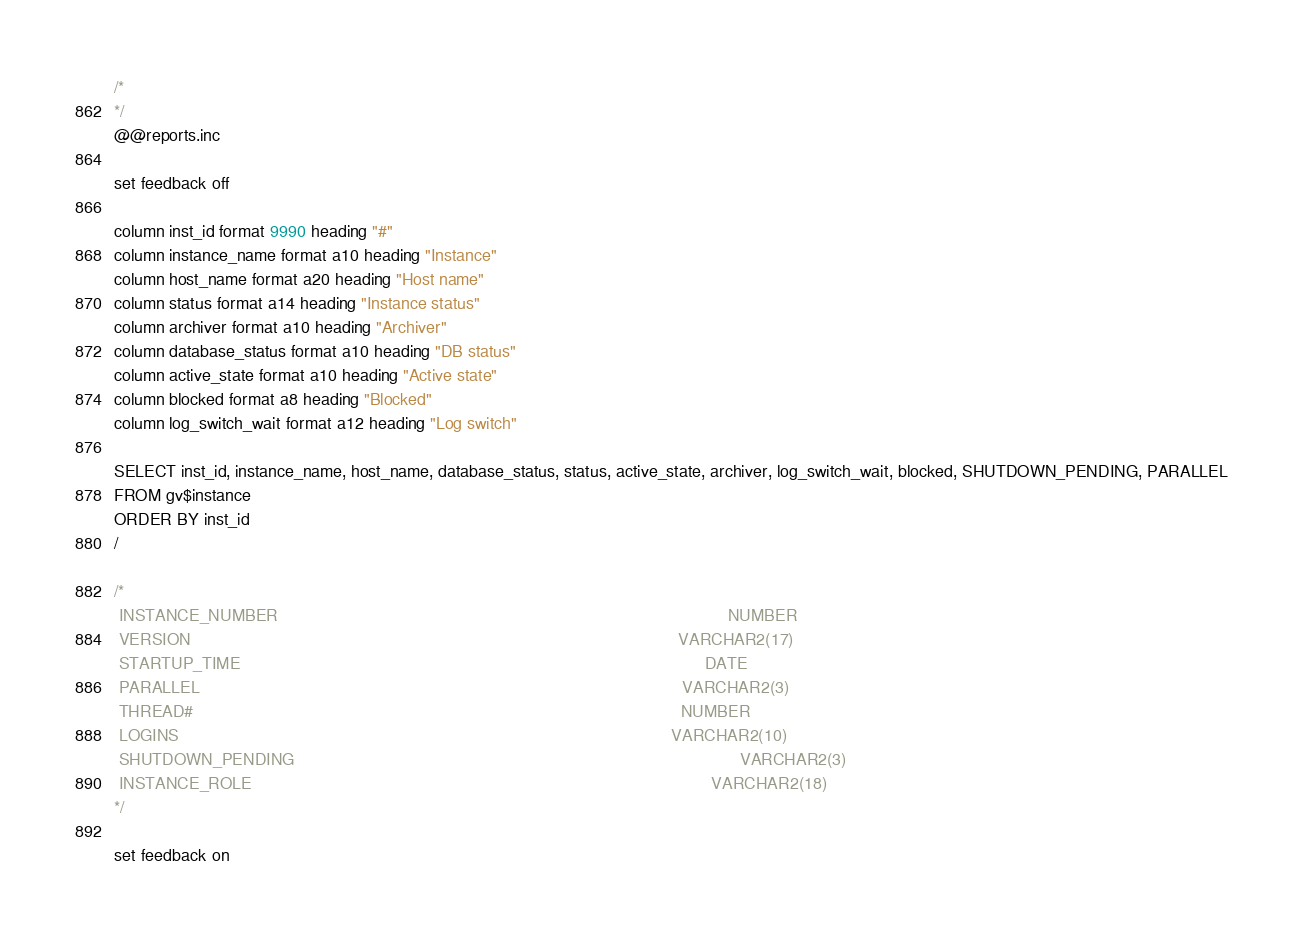<code> <loc_0><loc_0><loc_500><loc_500><_SQL_>/*
*/
@@reports.inc

set feedback off

column inst_id format 9990 heading "#"
column instance_name format a10 heading "Instance"
column host_name format a20 heading "Host name"
column status format a14 heading "Instance status"
column archiver format a10 heading "Archiver"
column database_status format a10 heading "DB status"
column active_state format a10 heading "Active state"
column blocked format a8 heading "Blocked"
column log_switch_wait format a12 heading "Log switch"

SELECT inst_id, instance_name, host_name, database_status, status, active_state, archiver, log_switch_wait, blocked, SHUTDOWN_PENDING, PARALLEL
FROM gv$instance
ORDER BY inst_id
/

/*
 INSTANCE_NUMBER                                                                                                NUMBER
 VERSION                                                                                                        VARCHAR2(17)
 STARTUP_TIME                                                                                                   DATE
 PARALLEL                                                                                                       VARCHAR2(3)
 THREAD#                                                                                                        NUMBER
 LOGINS                                                                                                         VARCHAR2(10)
 SHUTDOWN_PENDING                                                                                               VARCHAR2(3)
 INSTANCE_ROLE                                                                                                  VARCHAR2(18)
*/

set feedback on
</code> 